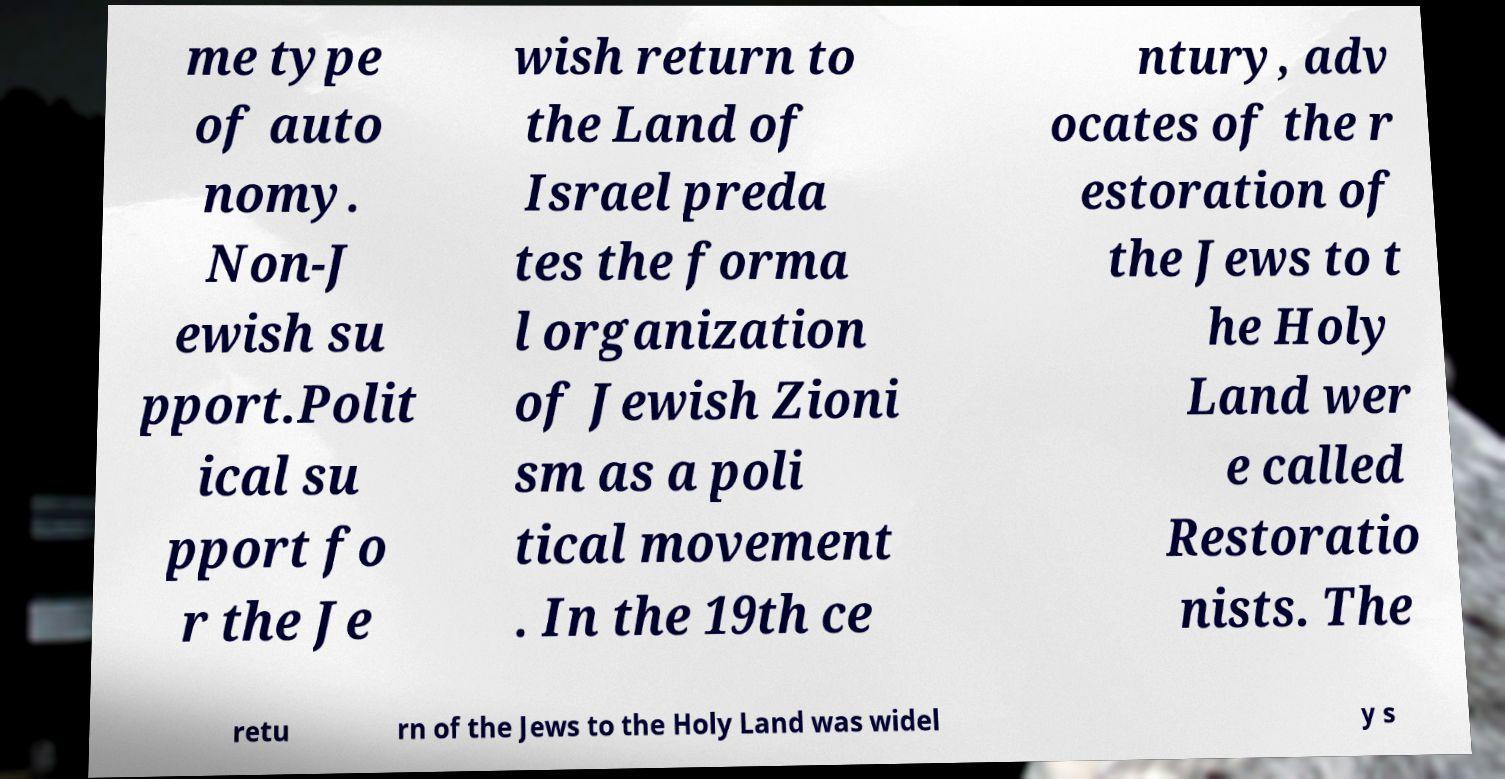Can you accurately transcribe the text from the provided image for me? me type of auto nomy. Non-J ewish su pport.Polit ical su pport fo r the Je wish return to the Land of Israel preda tes the forma l organization of Jewish Zioni sm as a poli tical movement . In the 19th ce ntury, adv ocates of the r estoration of the Jews to t he Holy Land wer e called Restoratio nists. The retu rn of the Jews to the Holy Land was widel y s 